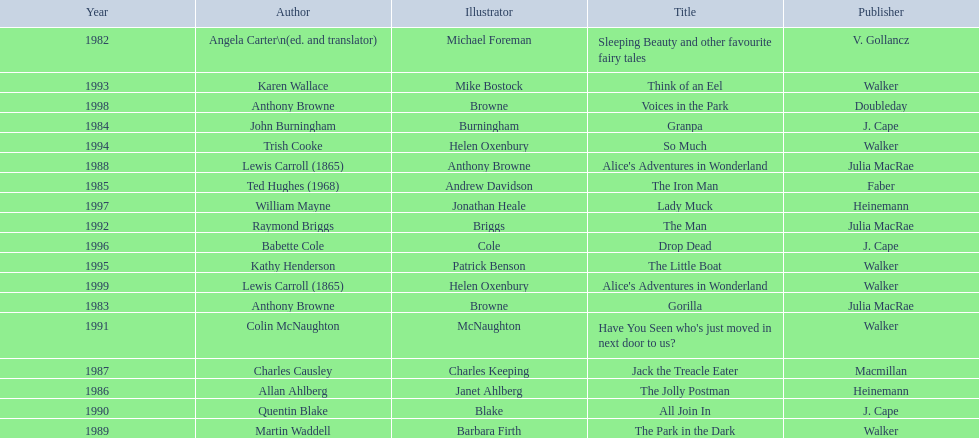How many number of titles are listed for the year 1991? 1. 